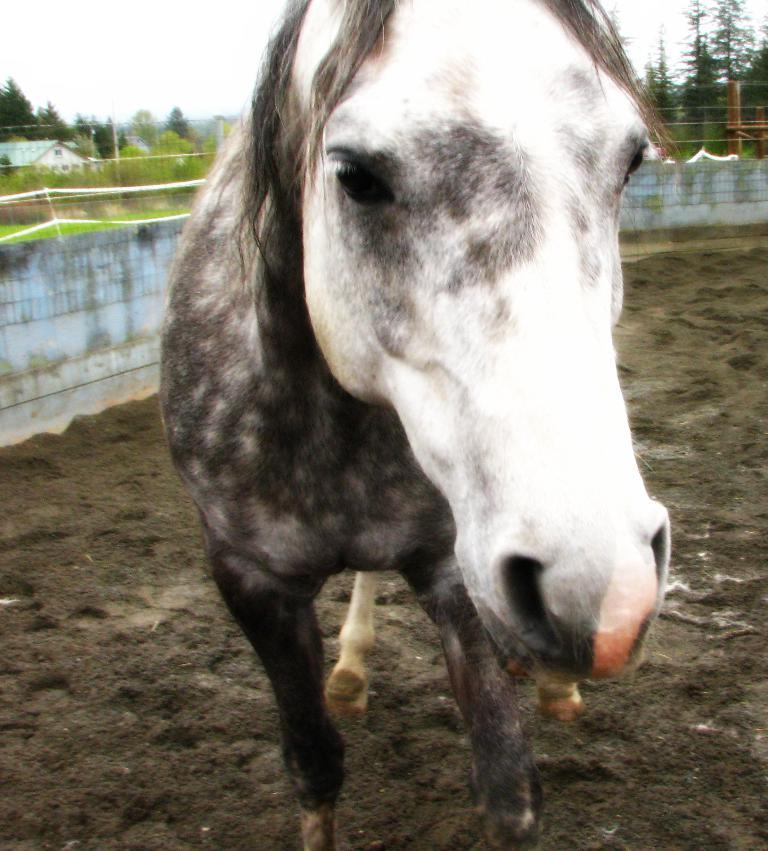What is the main subject in the center of the image? There is a horse in the center of the image. What is the color scheme of the image? The horse is in black and white color. What can be seen in the background of the image? Sky, clouds, trees, poles, a building, a wall, a roof, and a fence are visible in the background of the image. Can you describe the weather condition in the image? The presence of clouds in the sky suggests that it might be a partly cloudy day. What type of thrill can be seen in the image? There is no specific thrill or activity depicted in the image; it features a black and white horse with various background elements. What is the horse doing with the quiver in the image? There is no quiver present in the image, and the horse is not performing any specific action. 